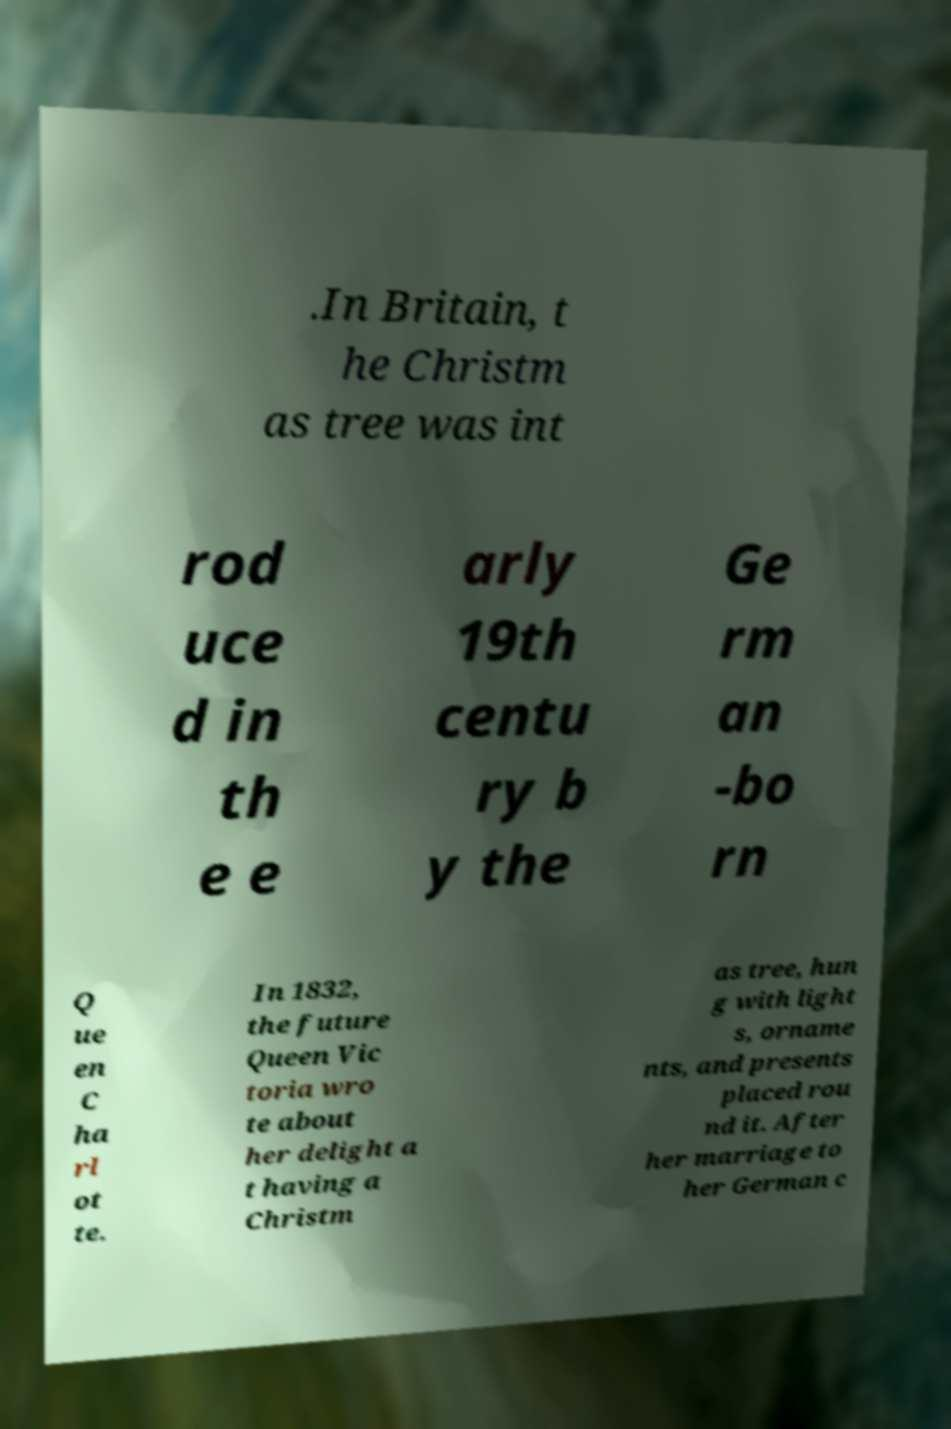Can you accurately transcribe the text from the provided image for me? .In Britain, t he Christm as tree was int rod uce d in th e e arly 19th centu ry b y the Ge rm an -bo rn Q ue en C ha rl ot te. In 1832, the future Queen Vic toria wro te about her delight a t having a Christm as tree, hun g with light s, orname nts, and presents placed rou nd it. After her marriage to her German c 